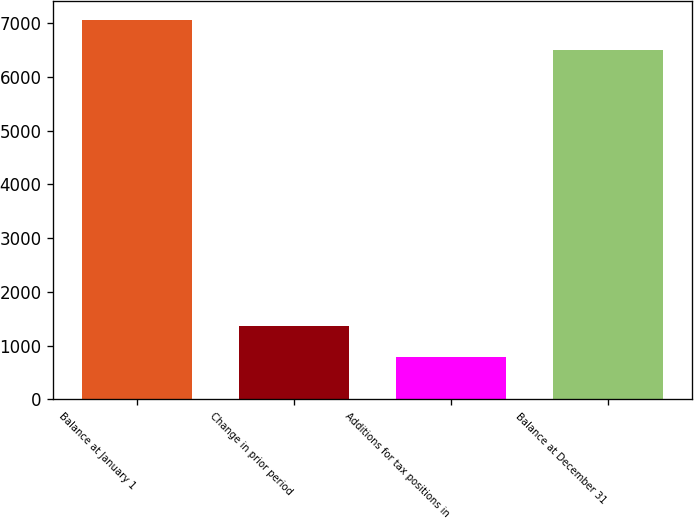<chart> <loc_0><loc_0><loc_500><loc_500><bar_chart><fcel>Balance at January 1<fcel>Change in prior period<fcel>Additions for tax positions in<fcel>Balance at December 31<nl><fcel>7065.3<fcel>1359.3<fcel>788<fcel>6494<nl></chart> 